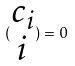Convert formula to latex. <formula><loc_0><loc_0><loc_500><loc_500>( \begin{matrix} c _ { i } \\ i \end{matrix} ) = 0</formula> 